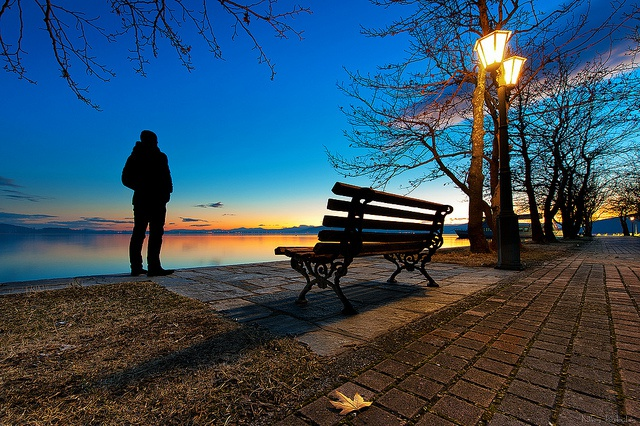Describe the objects in this image and their specific colors. I can see bench in darkblue, black, ivory, maroon, and gray tones and people in darkblue, black, teal, and gray tones in this image. 